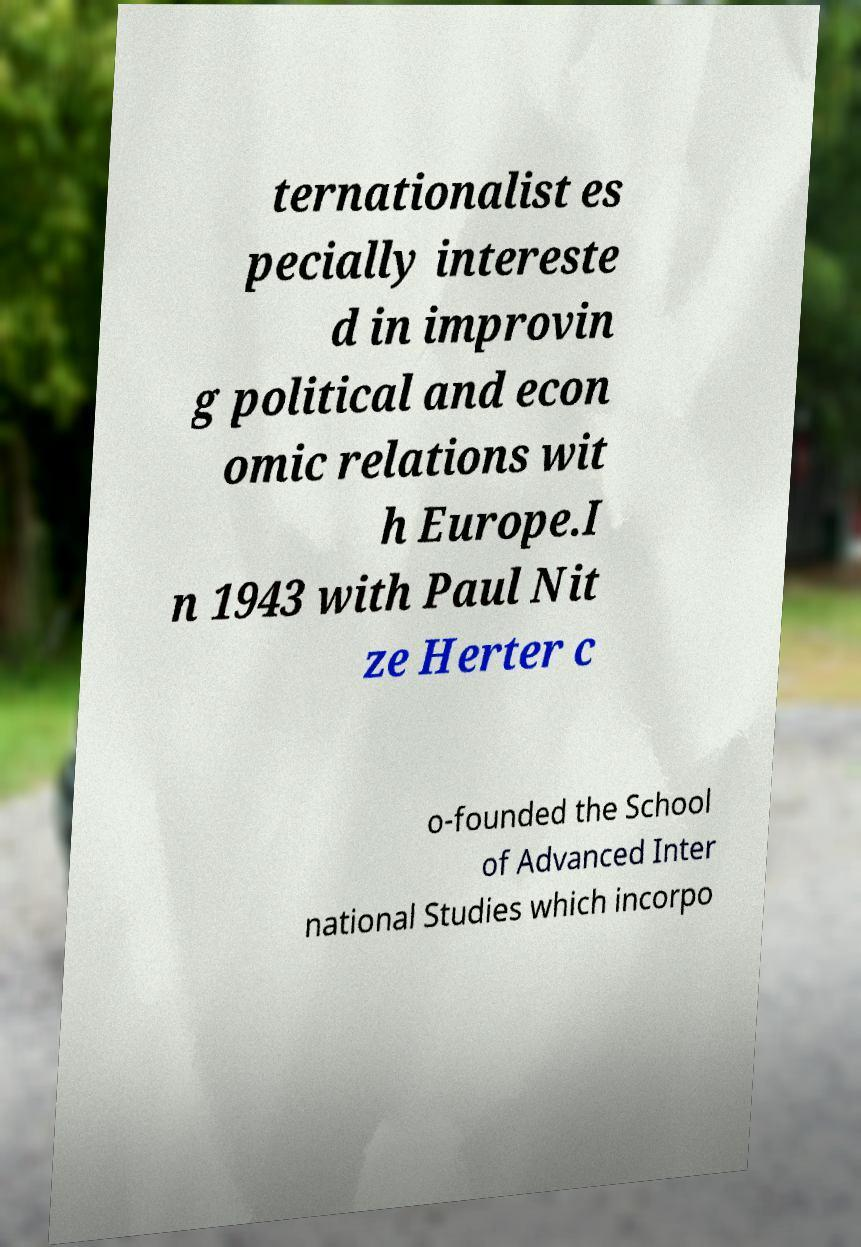I need the written content from this picture converted into text. Can you do that? ternationalist es pecially intereste d in improvin g political and econ omic relations wit h Europe.I n 1943 with Paul Nit ze Herter c o-founded the School of Advanced Inter national Studies which incorpo 